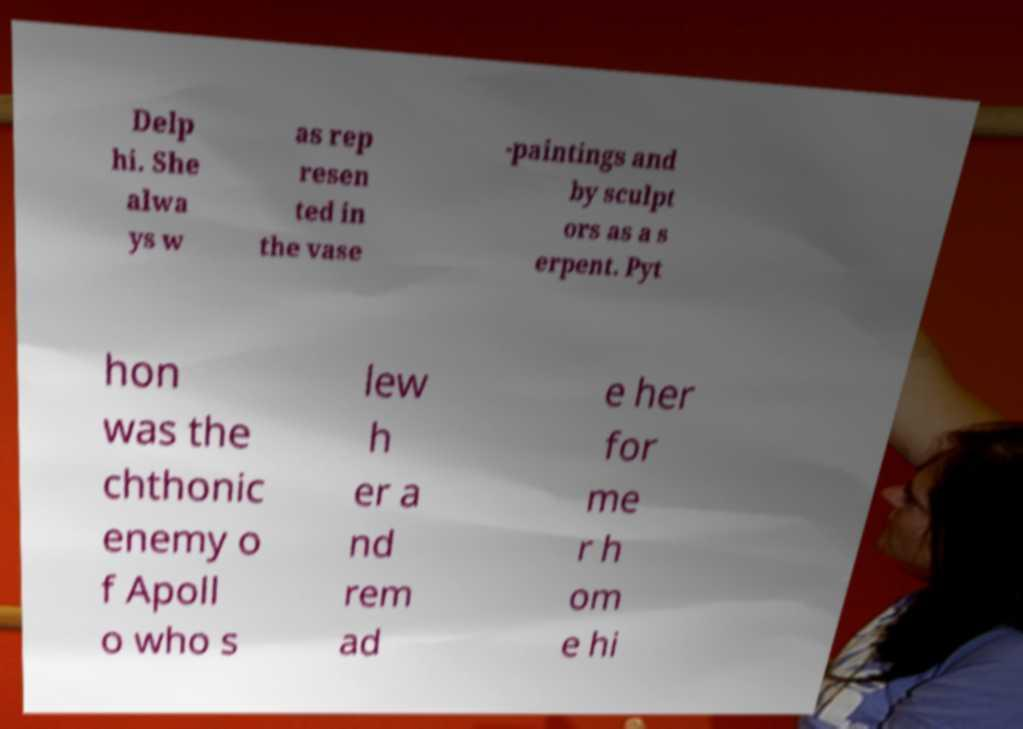I need the written content from this picture converted into text. Can you do that? Delp hi. She alwa ys w as rep resen ted in the vase -paintings and by sculpt ors as a s erpent. Pyt hon was the chthonic enemy o f Apoll o who s lew h er a nd rem ad e her for me r h om e hi 